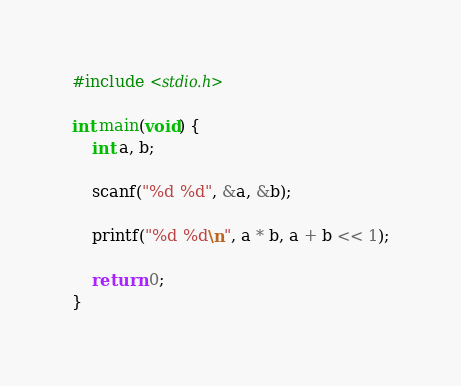Convert code to text. <code><loc_0><loc_0><loc_500><loc_500><_C_>#include <stdio.h>

int main(void) {
	int a, b;

	scanf("%d %d", &a, &b);

	printf("%d %d\n", a * b, a + b << 1);

	return 0;
}</code> 